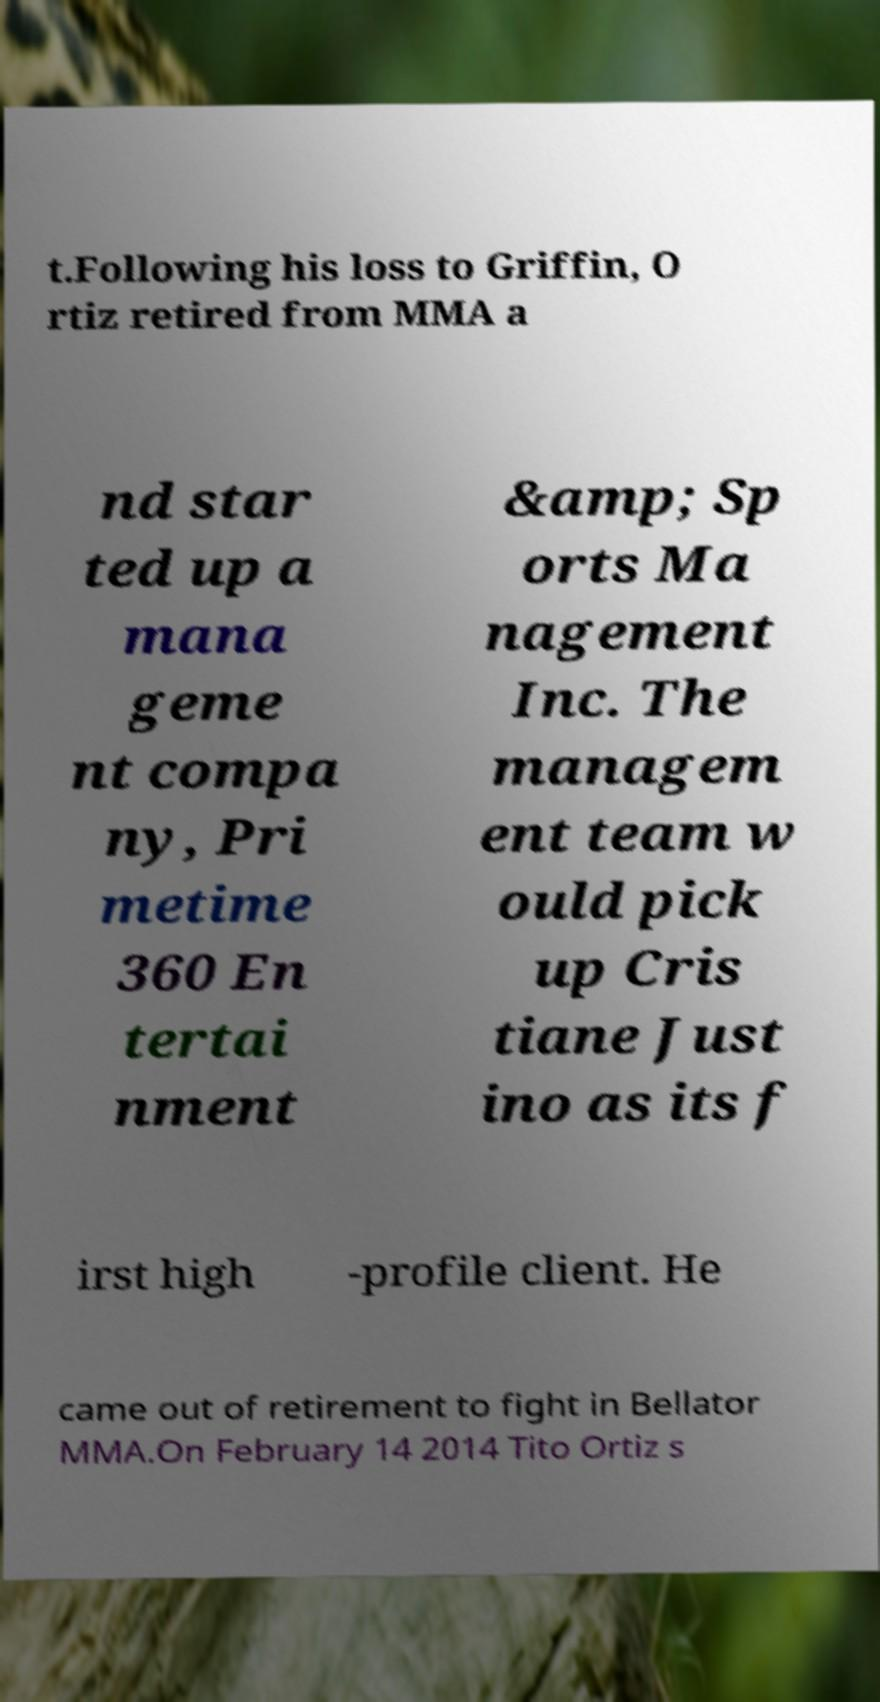For documentation purposes, I need the text within this image transcribed. Could you provide that? t.Following his loss to Griffin, O rtiz retired from MMA a nd star ted up a mana geme nt compa ny, Pri metime 360 En tertai nment &amp; Sp orts Ma nagement Inc. The managem ent team w ould pick up Cris tiane Just ino as its f irst high -profile client. He came out of retirement to fight in Bellator MMA.On February 14 2014 Tito Ortiz s 